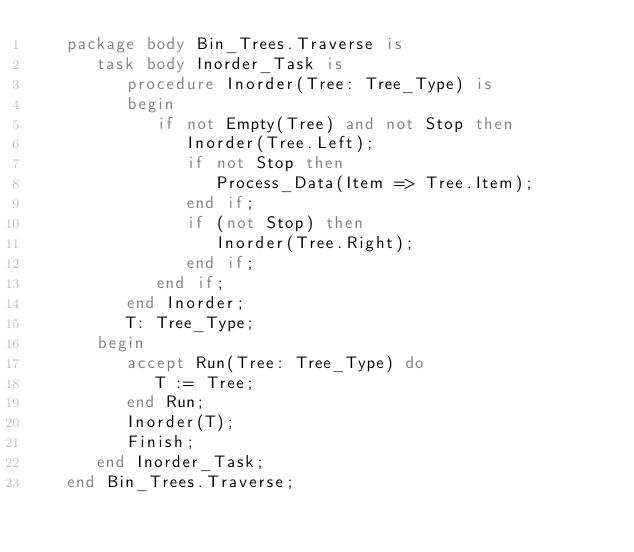Convert code to text. <code><loc_0><loc_0><loc_500><loc_500><_Ada_>   package body Bin_Trees.Traverse is
      task body Inorder_Task is
         procedure Inorder(Tree: Tree_Type) is
         begin
            if not Empty(Tree) and not Stop then
               Inorder(Tree.Left);
               if not Stop then
                  Process_Data(Item => Tree.Item);
               end if;
               if (not Stop) then
                  Inorder(Tree.Right);
               end if;
            end if;
         end Inorder;
         T: Tree_Type;
      begin
         accept Run(Tree: Tree_Type) do
            T := Tree;
         end Run;
         Inorder(T);
         Finish;
      end Inorder_Task;
   end Bin_Trees.Traverse;
</code> 